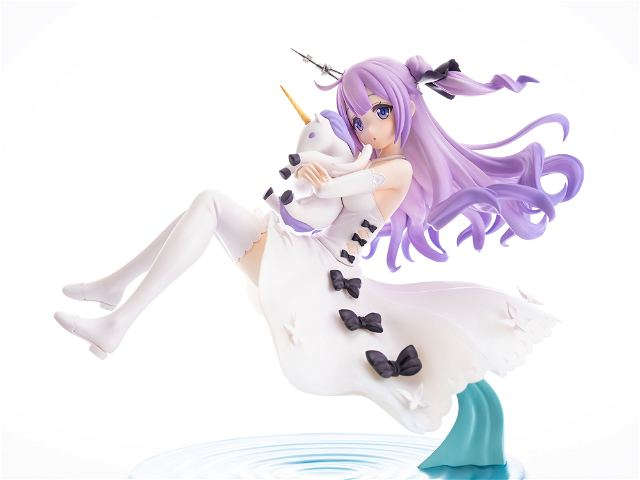What might the choice of colors in this character’s design suggest about her role or characteristics in her fantastical narrative? The use of soft purples and stark whites in the character's design can be indicative of her ethereal and pure nature within her story. Purple often represents mystery, magic, and royalty, which suggests she may hold a special or revered status in her world. White symbolizes purity and innocence, reinforcing her connection to themes of unspoiled beauty and magical integrity. These colors, combined, shape a narrative where she could either be a benevolent guardian or a mystical being of significant power and grace in her universe. 